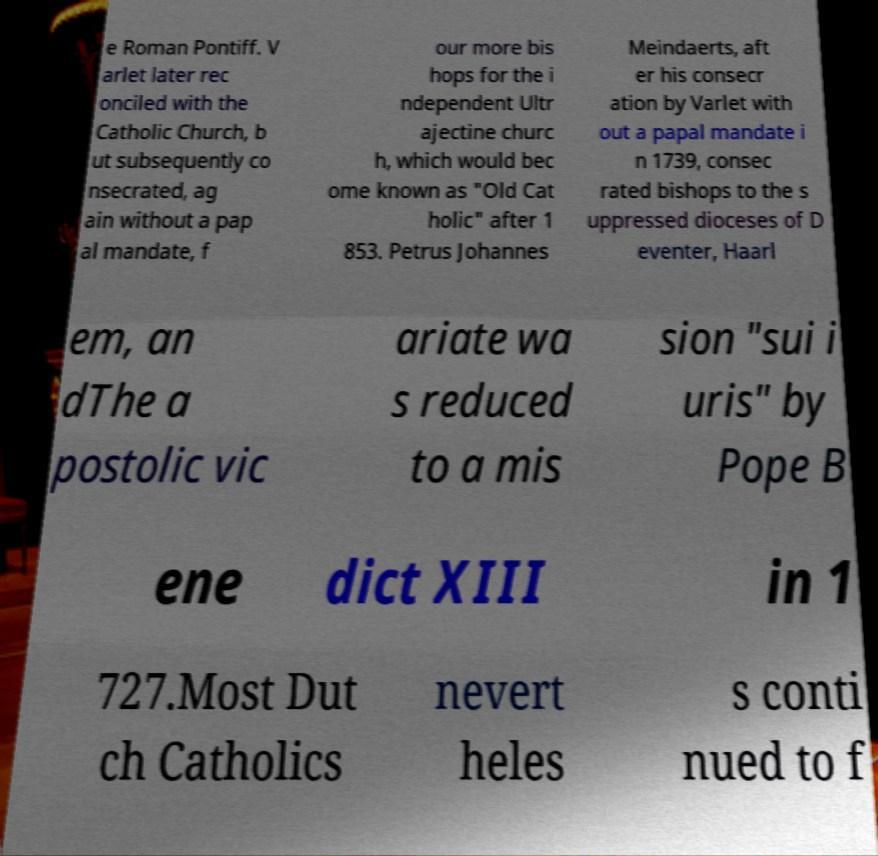For documentation purposes, I need the text within this image transcribed. Could you provide that? e Roman Pontiff. V arlet later rec onciled with the Catholic Church, b ut subsequently co nsecrated, ag ain without a pap al mandate, f our more bis hops for the i ndependent Ultr ajectine churc h, which would bec ome known as "Old Cat holic" after 1 853. Petrus Johannes Meindaerts, aft er his consecr ation by Varlet with out a papal mandate i n 1739, consec rated bishops to the s uppressed dioceses of D eventer, Haarl em, an dThe a postolic vic ariate wa s reduced to a mis sion "sui i uris" by Pope B ene dict XIII in 1 727.Most Dut ch Catholics nevert heles s conti nued to f 